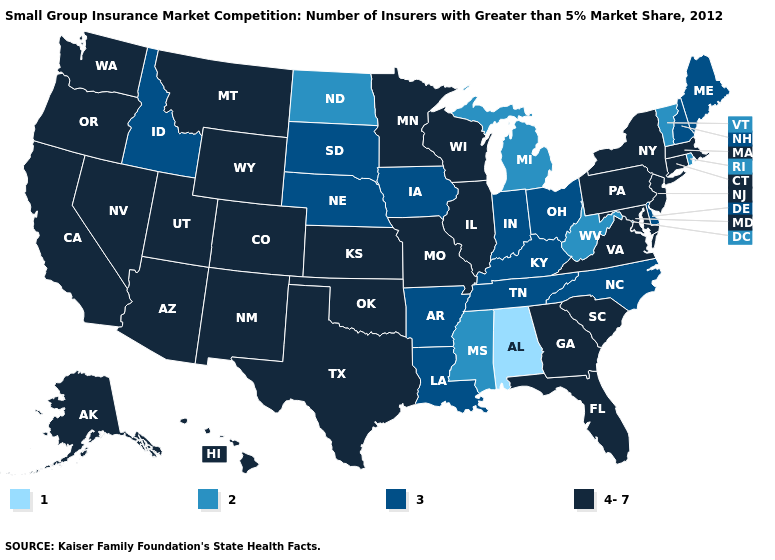What is the value of Indiana?
Be succinct. 3. Does Georgia have a higher value than Nebraska?
Concise answer only. Yes. Does the map have missing data?
Answer briefly. No. Does the first symbol in the legend represent the smallest category?
Keep it brief. Yes. What is the value of Arkansas?
Give a very brief answer. 3. Name the states that have a value in the range 1?
Answer briefly. Alabama. Does Mississippi have the highest value in the USA?
Write a very short answer. No. Does Florida have a lower value than Wyoming?
Concise answer only. No. Name the states that have a value in the range 4-7?
Give a very brief answer. Alaska, Arizona, California, Colorado, Connecticut, Florida, Georgia, Hawaii, Illinois, Kansas, Maryland, Massachusetts, Minnesota, Missouri, Montana, Nevada, New Jersey, New Mexico, New York, Oklahoma, Oregon, Pennsylvania, South Carolina, Texas, Utah, Virginia, Washington, Wisconsin, Wyoming. What is the highest value in the Northeast ?
Be succinct. 4-7. Name the states that have a value in the range 4-7?
Answer briefly. Alaska, Arizona, California, Colorado, Connecticut, Florida, Georgia, Hawaii, Illinois, Kansas, Maryland, Massachusetts, Minnesota, Missouri, Montana, Nevada, New Jersey, New Mexico, New York, Oklahoma, Oregon, Pennsylvania, South Carolina, Texas, Utah, Virginia, Washington, Wisconsin, Wyoming. What is the lowest value in states that border New Mexico?
Concise answer only. 4-7. What is the value of Vermont?
Short answer required. 2. Which states hav the highest value in the South?
Short answer required. Florida, Georgia, Maryland, Oklahoma, South Carolina, Texas, Virginia. What is the value of Connecticut?
Write a very short answer. 4-7. 